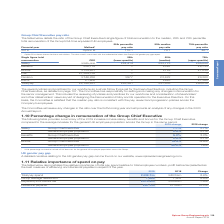According to Spirax Sarco Engineering Plc's financial document, Why was there an adjustment under Bonus for general employee population? 2018 percentage restated to include all UK bonuses for the general UK employee population across the Group. The document states: "* 2018 percentage restated to include all UK bonuses for the general UK employee population across the Group...." Also, What was the 2019 increase in base salary, benefits and bonus for the Group Chief Executive compared against? compared to the average increase for the general UK employee population across the Group in the same period. The document states: "benefits and bonus for the Group Chief Executive compared to the average increase for the general UK employee population across the Group in the same ..." Also, What are the components of remuneration reflected in the table? The document contains multiple relevant values: Salary, Benefits, Bonus. From the document: "e 5.2% 3.2% General employee population 2.9% 2.7% Bonus Group Chief Executive 15.5% -4.9% General employee population* 22.2% 1.6% e 7.7% 2.7% General ..." Additionally, In which year was the change in salary for the general employee population larger? According to the financial document, 2019. The relevant text states: "2019 change 2018 change Salary Group Chief Executive 7.7% 2.7% General employee population 2.9% 2.7% Ben..." Also, can you calculate: What was the absolute change in the change in salary for the group chief executive in 2019 from 2018?  Based on the calculation: 7.7%-2.7%, the result is 5 (percentage). This is based on the information: "nge 2018 change Salary Group Chief Executive 7.7% 2.7% General employee population 2.9% 2.7% Benefits Group Chief Executive 5.2% 3.2% General employee po 9 change 2018 change Salary Group Chief Execut..." The key data points involved are: 2.7, 7.7. Also, can you calculate: What was the percentage change in the change in salary for the group chief executive in 2019 from 2018?  To answer this question, I need to perform calculations using the financial data. The calculation is: (7.7-2.7)/2.7, which equals 185.19 (percentage). This is based on the information: "nge 2018 change Salary Group Chief Executive 7.7% 2.7% General employee population 2.9% 2.7% Benefits Group Chief Executive 5.2% 3.2% General employee po 9 change 2018 change Salary Group Chief Execut..." The key data points involved are: 2.7, 7.7. 